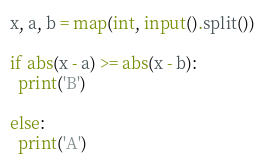<code> <loc_0><loc_0><loc_500><loc_500><_Python_>x, a, b = map(int, input().split())

if abs(x - a) >= abs(x - b):
  print('B')

else:
  print('A')
</code> 